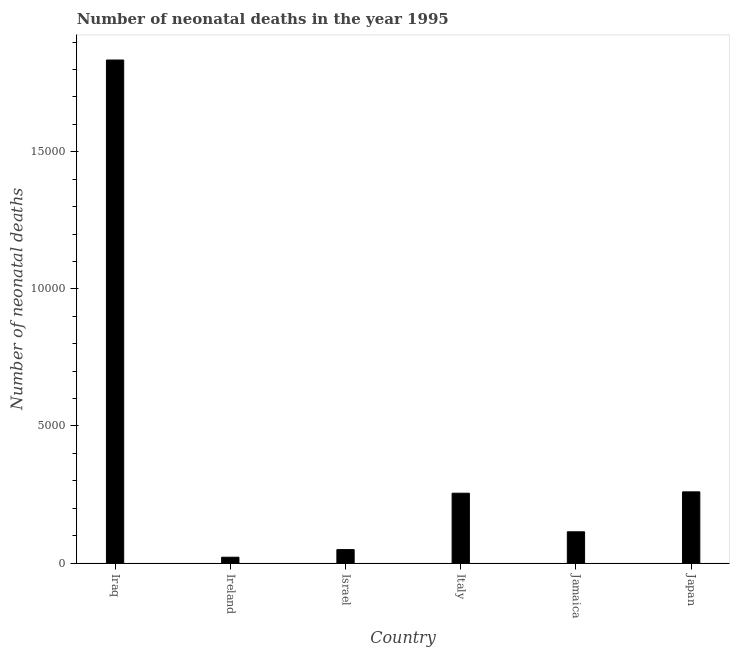Does the graph contain any zero values?
Give a very brief answer. No. What is the title of the graph?
Your response must be concise. Number of neonatal deaths in the year 1995. What is the label or title of the Y-axis?
Offer a terse response. Number of neonatal deaths. What is the number of neonatal deaths in Italy?
Give a very brief answer. 2549. Across all countries, what is the maximum number of neonatal deaths?
Offer a very short reply. 1.83e+04. Across all countries, what is the minimum number of neonatal deaths?
Offer a terse response. 214. In which country was the number of neonatal deaths maximum?
Offer a very short reply. Iraq. In which country was the number of neonatal deaths minimum?
Your answer should be compact. Ireland. What is the sum of the number of neonatal deaths?
Keep it short and to the point. 2.53e+04. What is the difference between the number of neonatal deaths in Iraq and Japan?
Your response must be concise. 1.57e+04. What is the average number of neonatal deaths per country?
Provide a succinct answer. 4223. What is the median number of neonatal deaths?
Keep it short and to the point. 1845. In how many countries, is the number of neonatal deaths greater than 7000 ?
Provide a short and direct response. 1. What is the ratio of the number of neonatal deaths in Ireland to that in Italy?
Keep it short and to the point. 0.08. What is the difference between the highest and the second highest number of neonatal deaths?
Provide a succinct answer. 1.57e+04. Is the sum of the number of neonatal deaths in Ireland and Japan greater than the maximum number of neonatal deaths across all countries?
Keep it short and to the point. No. What is the difference between the highest and the lowest number of neonatal deaths?
Offer a very short reply. 1.81e+04. Are all the bars in the graph horizontal?
Your answer should be compact. No. How many countries are there in the graph?
Provide a short and direct response. 6. What is the difference between two consecutive major ticks on the Y-axis?
Provide a short and direct response. 5000. What is the Number of neonatal deaths in Iraq?
Keep it short and to the point. 1.83e+04. What is the Number of neonatal deaths of Ireland?
Provide a succinct answer. 214. What is the Number of neonatal deaths in Israel?
Make the answer very short. 492. What is the Number of neonatal deaths of Italy?
Offer a terse response. 2549. What is the Number of neonatal deaths in Jamaica?
Give a very brief answer. 1141. What is the Number of neonatal deaths in Japan?
Keep it short and to the point. 2598. What is the difference between the Number of neonatal deaths in Iraq and Ireland?
Offer a terse response. 1.81e+04. What is the difference between the Number of neonatal deaths in Iraq and Israel?
Ensure brevity in your answer.  1.79e+04. What is the difference between the Number of neonatal deaths in Iraq and Italy?
Provide a succinct answer. 1.58e+04. What is the difference between the Number of neonatal deaths in Iraq and Jamaica?
Give a very brief answer. 1.72e+04. What is the difference between the Number of neonatal deaths in Iraq and Japan?
Give a very brief answer. 1.57e+04. What is the difference between the Number of neonatal deaths in Ireland and Israel?
Offer a terse response. -278. What is the difference between the Number of neonatal deaths in Ireland and Italy?
Offer a very short reply. -2335. What is the difference between the Number of neonatal deaths in Ireland and Jamaica?
Offer a very short reply. -927. What is the difference between the Number of neonatal deaths in Ireland and Japan?
Provide a short and direct response. -2384. What is the difference between the Number of neonatal deaths in Israel and Italy?
Offer a very short reply. -2057. What is the difference between the Number of neonatal deaths in Israel and Jamaica?
Keep it short and to the point. -649. What is the difference between the Number of neonatal deaths in Israel and Japan?
Give a very brief answer. -2106. What is the difference between the Number of neonatal deaths in Italy and Jamaica?
Keep it short and to the point. 1408. What is the difference between the Number of neonatal deaths in Italy and Japan?
Provide a succinct answer. -49. What is the difference between the Number of neonatal deaths in Jamaica and Japan?
Provide a short and direct response. -1457. What is the ratio of the Number of neonatal deaths in Iraq to that in Ireland?
Give a very brief answer. 85.73. What is the ratio of the Number of neonatal deaths in Iraq to that in Israel?
Give a very brief answer. 37.29. What is the ratio of the Number of neonatal deaths in Iraq to that in Italy?
Your response must be concise. 7.2. What is the ratio of the Number of neonatal deaths in Iraq to that in Jamaica?
Ensure brevity in your answer.  16.08. What is the ratio of the Number of neonatal deaths in Iraq to that in Japan?
Your response must be concise. 7.06. What is the ratio of the Number of neonatal deaths in Ireland to that in Israel?
Your answer should be compact. 0.43. What is the ratio of the Number of neonatal deaths in Ireland to that in Italy?
Keep it short and to the point. 0.08. What is the ratio of the Number of neonatal deaths in Ireland to that in Jamaica?
Your answer should be very brief. 0.19. What is the ratio of the Number of neonatal deaths in Ireland to that in Japan?
Your answer should be compact. 0.08. What is the ratio of the Number of neonatal deaths in Israel to that in Italy?
Your answer should be very brief. 0.19. What is the ratio of the Number of neonatal deaths in Israel to that in Jamaica?
Your answer should be compact. 0.43. What is the ratio of the Number of neonatal deaths in Israel to that in Japan?
Your answer should be compact. 0.19. What is the ratio of the Number of neonatal deaths in Italy to that in Jamaica?
Provide a succinct answer. 2.23. What is the ratio of the Number of neonatal deaths in Jamaica to that in Japan?
Give a very brief answer. 0.44. 